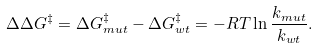Convert formula to latex. <formula><loc_0><loc_0><loc_500><loc_500>\Delta \Delta G ^ { \ddag } = \Delta G ^ { \ddag } _ { m u t } - \Delta G ^ { \ddag } _ { w t } = - R T \ln \frac { k _ { m u t } } { k _ { w t } } .</formula> 